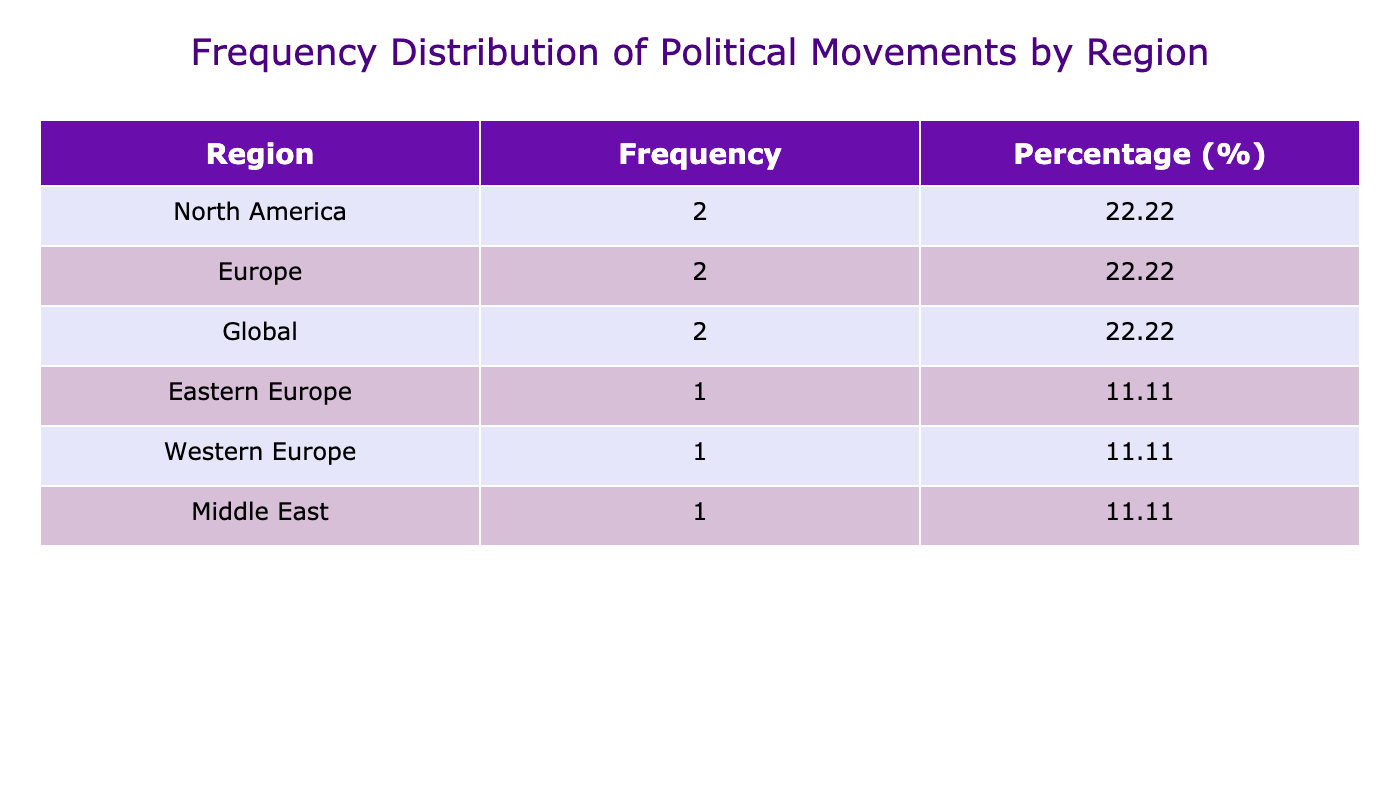What region has the highest frequency of political movements? The table shows that Europe has the highest frequency of political movements with a total of 4 occurrences.
Answer: Europe How many political movements took place in North America? The table lists 2 political movements in North America: the American Revolution and the Civil Rights Movement.
Answer: 2 What percentage of political movements originated from the Middle East? There is 1 political movement from the Middle East (the Arab Spring) out of a total of 9 movements, which gives a percentage of (1/9) * 100 = 11.11%.
Answer: 11.11% Is it true that the Global region has more political movements than Western Europe? The table displays 3 political movements in the Global region and 1 in Western Europe, which means the statement is true.
Answer: Yes What is the difference in the number of political movements between Europe and North America? Europe has 4 movements, while North America has 2. The difference is calculated as 4 - 2 = 2.
Answer: 2 Which year had a significant political movement that re-energized discussions on racial justice? The Black Lives Matter movement, which re-energized discussions on racial justice, occurred in 2020.
Answer: 2020 What is the total number of political movements listed in the table? The table presents a total of 9 political movements when counting each entry.
Answer: 9 If we combine the frequencies of political movements from North America and Europe, what is the sum? North America has 2 movements, while Europe has 4. Adding these together gives 2 + 4 = 6.
Answer: 6 In which region did the Student Protests occur, and what was their significance? Student Protests occurred globally and challenged authority and traditional societal norms across multiple countries.
Answer: Global, challenged authority and norms 